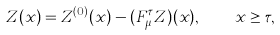<formula> <loc_0><loc_0><loc_500><loc_500>Z ( x ) = Z ^ { ( 0 ) } ( x ) - ( F _ { \mu } ^ { \tau } Z ) ( x ) , \quad x \geq \tau ,</formula> 